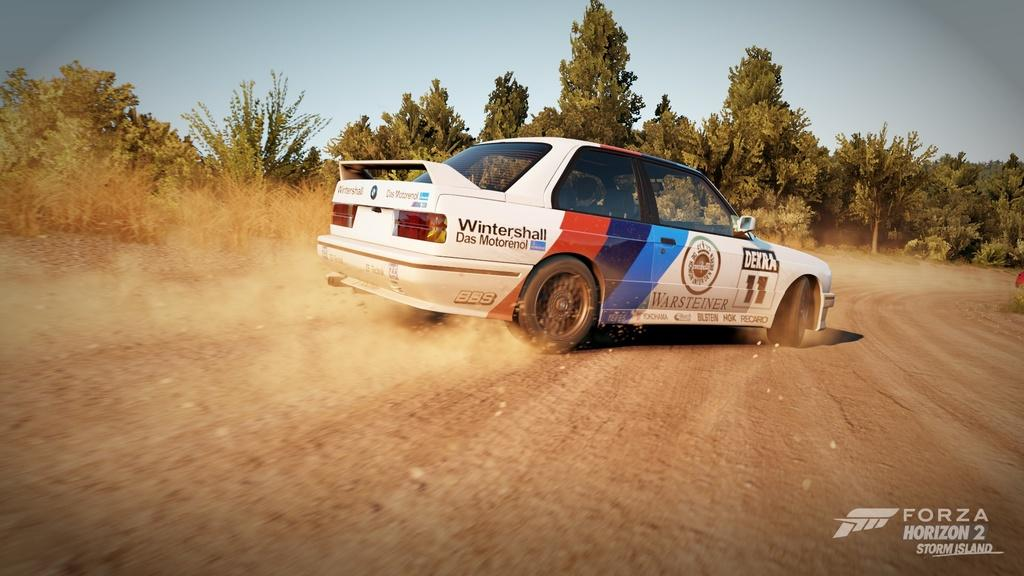What is the main subject of the image? The main subject of the image is a car. What is the car doing in the image? The car is moving in the image. What color is the car? The car is white in color. What can be seen in the background of the image? There are trees visible in the background of the image. What type of badge is the beggar wearing in the image? There is no beggar or badge present in the image; it features a moving white car with trees in the background. 